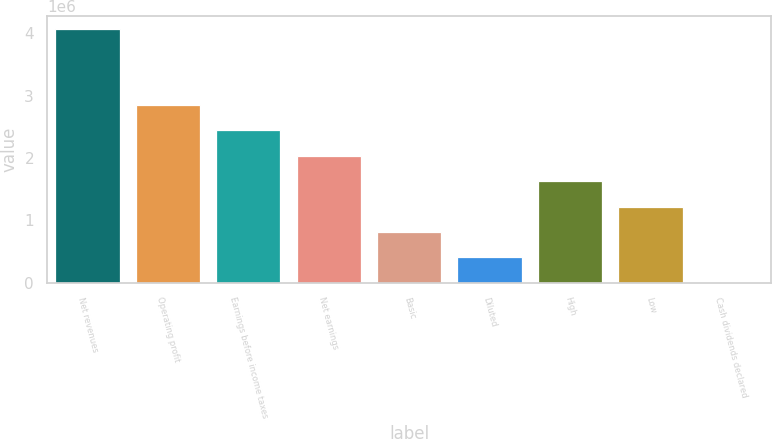<chart> <loc_0><loc_0><loc_500><loc_500><bar_chart><fcel>Net revenues<fcel>Operating profit<fcel>Earnings before income taxes<fcel>Net earnings<fcel>Basic<fcel>Diluted<fcel>High<fcel>Low<fcel>Cash dividends declared<nl><fcel>4.06795e+06<fcel>2.84756e+06<fcel>2.44077e+06<fcel>2.03397e+06<fcel>813590<fcel>406795<fcel>1.62718e+06<fcel>1.22038e+06<fcel>0.8<nl></chart> 